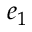Convert formula to latex. <formula><loc_0><loc_0><loc_500><loc_500>e _ { 1 }</formula> 